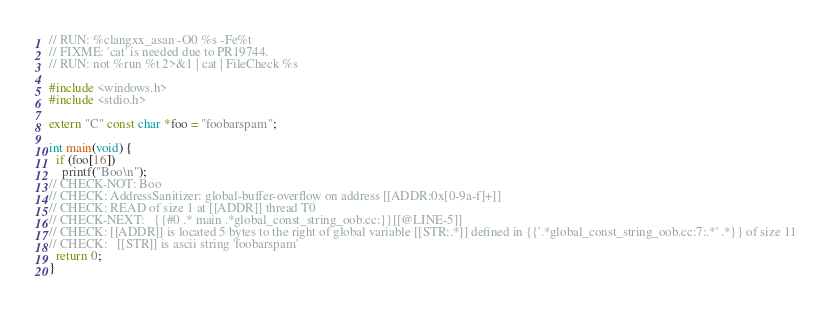Convert code to text. <code><loc_0><loc_0><loc_500><loc_500><_C++_>// RUN: %clangxx_asan -O0 %s -Fe%t
// FIXME: 'cat' is needed due to PR19744.
// RUN: not %run %t 2>&1 | cat | FileCheck %s

#include <windows.h>
#include <stdio.h>

extern "C" const char *foo = "foobarspam";

int main(void) {
  if (foo[16])
    printf("Boo\n");
// CHECK-NOT: Boo
// CHECK: AddressSanitizer: global-buffer-overflow on address [[ADDR:0x[0-9a-f]+]]
// CHECK: READ of size 1 at [[ADDR]] thread T0
// CHECK-NEXT:   {{#0 .* main .*global_const_string_oob.cc:}}[[@LINE-5]]
// CHECK: [[ADDR]] is located 5 bytes to the right of global variable [[STR:.*]] defined in {{'.*global_const_string_oob.cc:7:.*' .*}} of size 11
// CHECK:   [[STR]] is ascii string 'foobarspam'
  return 0;
}

</code> 